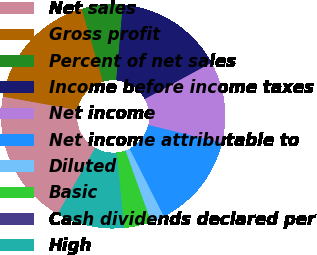Convert chart to OTSL. <chart><loc_0><loc_0><loc_500><loc_500><pie_chart><fcel>Net sales<fcel>Gross profit<fcel>Percent of net sales<fcel>Income before income taxes<fcel>Net income<fcel>Net income attributable to<fcel>Diluted<fcel>Basic<fcel>Cash dividends declared per<fcel>High<nl><fcel>19.61%<fcel>17.65%<fcel>5.88%<fcel>15.68%<fcel>11.76%<fcel>13.72%<fcel>1.96%<fcel>3.92%<fcel>0.0%<fcel>9.8%<nl></chart> 